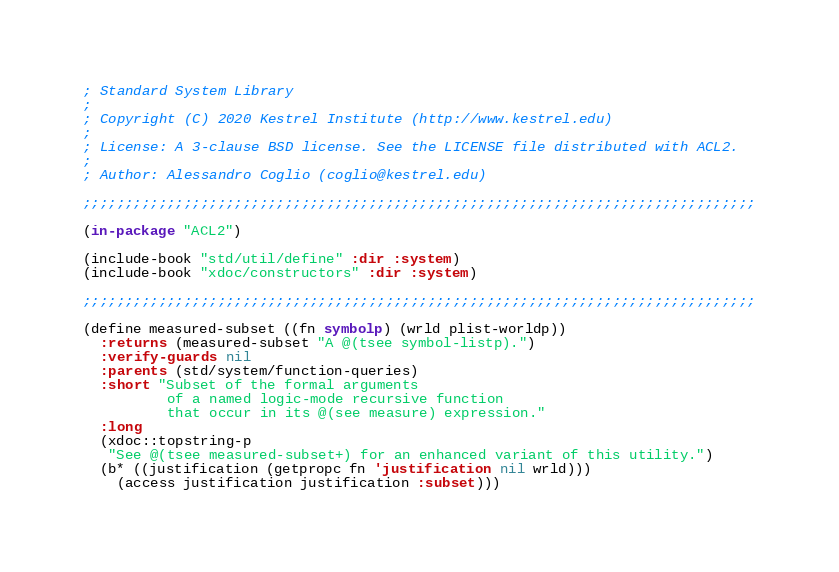Convert code to text. <code><loc_0><loc_0><loc_500><loc_500><_Lisp_>; Standard System Library
;
; Copyright (C) 2020 Kestrel Institute (http://www.kestrel.edu)
;
; License: A 3-clause BSD license. See the LICENSE file distributed with ACL2.
;
; Author: Alessandro Coglio (coglio@kestrel.edu)

;;;;;;;;;;;;;;;;;;;;;;;;;;;;;;;;;;;;;;;;;;;;;;;;;;;;;;;;;;;;;;;;;;;;;;;;;;;;;;;;

(in-package "ACL2")

(include-book "std/util/define" :dir :system)
(include-book "xdoc/constructors" :dir :system)

;;;;;;;;;;;;;;;;;;;;;;;;;;;;;;;;;;;;;;;;;;;;;;;;;;;;;;;;;;;;;;;;;;;;;;;;;;;;;;;;

(define measured-subset ((fn symbolp) (wrld plist-worldp))
  :returns (measured-subset "A @(tsee symbol-listp).")
  :verify-guards nil
  :parents (std/system/function-queries)
  :short "Subset of the formal arguments
          of a named logic-mode recursive function
          that occur in its @(see measure) expression."
  :long
  (xdoc::topstring-p
   "See @(tsee measured-subset+) for an enhanced variant of this utility.")
  (b* ((justification (getpropc fn 'justification nil wrld)))
    (access justification justification :subset)))
</code> 